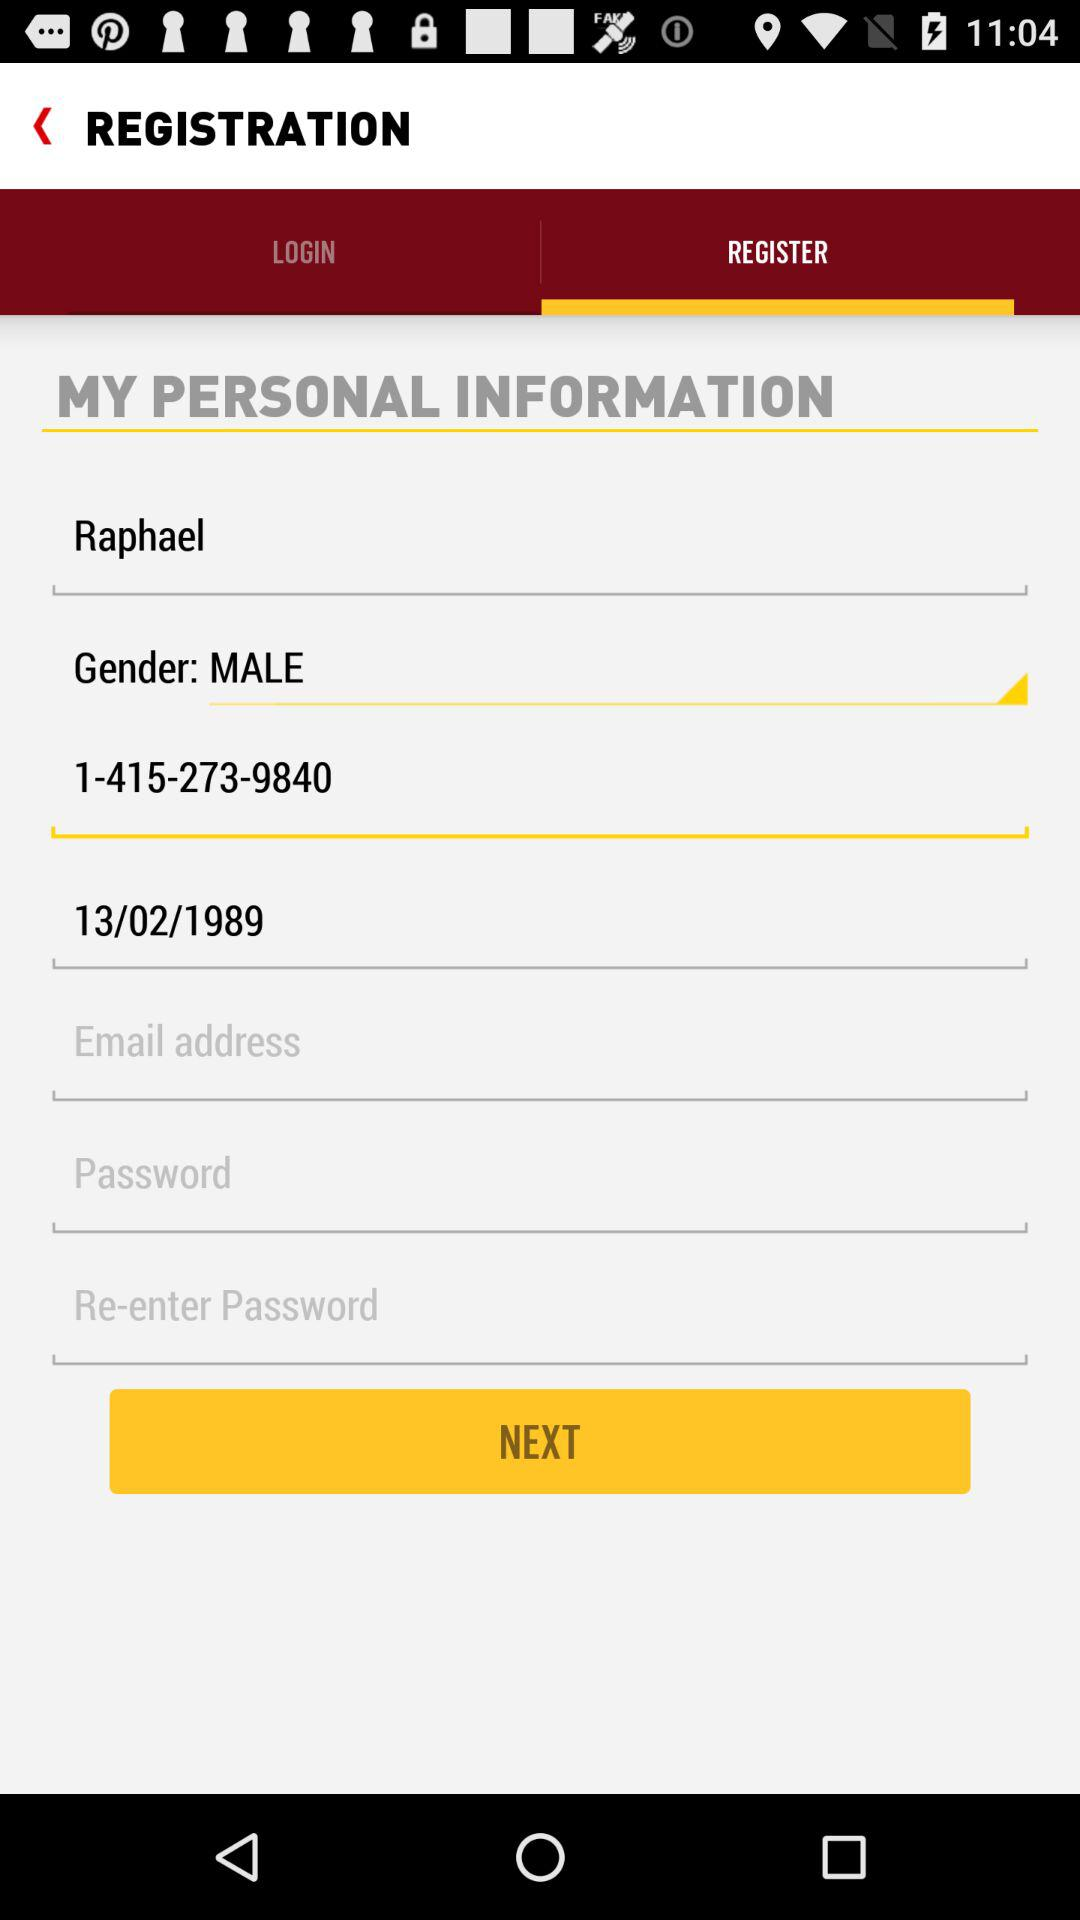What is the date of birth given on the screen? The date of birth given on the screen is February 13, 1989. 